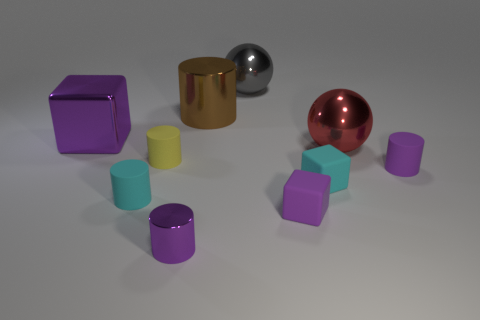Subtract all small purple metallic cylinders. How many cylinders are left? 4 Subtract all cyan cylinders. How many cylinders are left? 4 Subtract all gray cylinders. Subtract all yellow blocks. How many cylinders are left? 5 Subtract all cubes. How many objects are left? 7 Add 4 red metal spheres. How many red metal spheres are left? 5 Add 4 large blue objects. How many large blue objects exist? 4 Subtract 1 red balls. How many objects are left? 9 Subtract all small gray shiny blocks. Subtract all cyan objects. How many objects are left? 8 